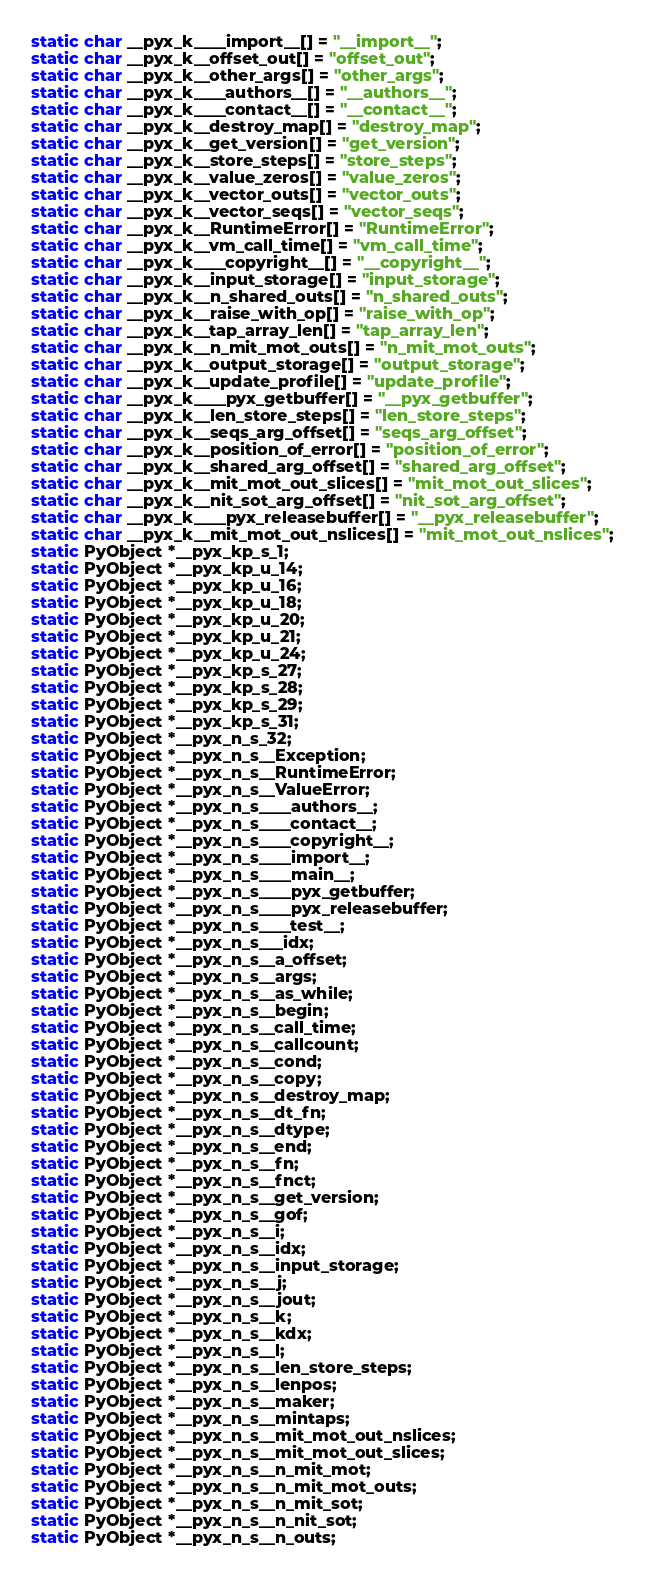<code> <loc_0><loc_0><loc_500><loc_500><_C_>static char __pyx_k____import__[] = "__import__";
static char __pyx_k__offset_out[] = "offset_out";
static char __pyx_k__other_args[] = "other_args";
static char __pyx_k____authors__[] = "__authors__";
static char __pyx_k____contact__[] = "__contact__";
static char __pyx_k__destroy_map[] = "destroy_map";
static char __pyx_k__get_version[] = "get_version";
static char __pyx_k__store_steps[] = "store_steps";
static char __pyx_k__value_zeros[] = "value_zeros";
static char __pyx_k__vector_outs[] = "vector_outs";
static char __pyx_k__vector_seqs[] = "vector_seqs";
static char __pyx_k__RuntimeError[] = "RuntimeError";
static char __pyx_k__vm_call_time[] = "vm_call_time";
static char __pyx_k____copyright__[] = "__copyright__";
static char __pyx_k__input_storage[] = "input_storage";
static char __pyx_k__n_shared_outs[] = "n_shared_outs";
static char __pyx_k__raise_with_op[] = "raise_with_op";
static char __pyx_k__tap_array_len[] = "tap_array_len";
static char __pyx_k__n_mit_mot_outs[] = "n_mit_mot_outs";
static char __pyx_k__output_storage[] = "output_storage";
static char __pyx_k__update_profile[] = "update_profile";
static char __pyx_k____pyx_getbuffer[] = "__pyx_getbuffer";
static char __pyx_k__len_store_steps[] = "len_store_steps";
static char __pyx_k__seqs_arg_offset[] = "seqs_arg_offset";
static char __pyx_k__position_of_error[] = "position_of_error";
static char __pyx_k__shared_arg_offset[] = "shared_arg_offset";
static char __pyx_k__mit_mot_out_slices[] = "mit_mot_out_slices";
static char __pyx_k__nit_sot_arg_offset[] = "nit_sot_arg_offset";
static char __pyx_k____pyx_releasebuffer[] = "__pyx_releasebuffer";
static char __pyx_k__mit_mot_out_nslices[] = "mit_mot_out_nslices";
static PyObject *__pyx_kp_s_1;
static PyObject *__pyx_kp_u_14;
static PyObject *__pyx_kp_u_16;
static PyObject *__pyx_kp_u_18;
static PyObject *__pyx_kp_u_20;
static PyObject *__pyx_kp_u_21;
static PyObject *__pyx_kp_u_24;
static PyObject *__pyx_kp_s_27;
static PyObject *__pyx_kp_s_28;
static PyObject *__pyx_kp_s_29;
static PyObject *__pyx_kp_s_31;
static PyObject *__pyx_n_s_32;
static PyObject *__pyx_n_s__Exception;
static PyObject *__pyx_n_s__RuntimeError;
static PyObject *__pyx_n_s__ValueError;
static PyObject *__pyx_n_s____authors__;
static PyObject *__pyx_n_s____contact__;
static PyObject *__pyx_n_s____copyright__;
static PyObject *__pyx_n_s____import__;
static PyObject *__pyx_n_s____main__;
static PyObject *__pyx_n_s____pyx_getbuffer;
static PyObject *__pyx_n_s____pyx_releasebuffer;
static PyObject *__pyx_n_s____test__;
static PyObject *__pyx_n_s___idx;
static PyObject *__pyx_n_s__a_offset;
static PyObject *__pyx_n_s__args;
static PyObject *__pyx_n_s__as_while;
static PyObject *__pyx_n_s__begin;
static PyObject *__pyx_n_s__call_time;
static PyObject *__pyx_n_s__callcount;
static PyObject *__pyx_n_s__cond;
static PyObject *__pyx_n_s__copy;
static PyObject *__pyx_n_s__destroy_map;
static PyObject *__pyx_n_s__dt_fn;
static PyObject *__pyx_n_s__dtype;
static PyObject *__pyx_n_s__end;
static PyObject *__pyx_n_s__fn;
static PyObject *__pyx_n_s__fnct;
static PyObject *__pyx_n_s__get_version;
static PyObject *__pyx_n_s__gof;
static PyObject *__pyx_n_s__i;
static PyObject *__pyx_n_s__idx;
static PyObject *__pyx_n_s__input_storage;
static PyObject *__pyx_n_s__j;
static PyObject *__pyx_n_s__jout;
static PyObject *__pyx_n_s__k;
static PyObject *__pyx_n_s__kdx;
static PyObject *__pyx_n_s__l;
static PyObject *__pyx_n_s__len_store_steps;
static PyObject *__pyx_n_s__lenpos;
static PyObject *__pyx_n_s__maker;
static PyObject *__pyx_n_s__mintaps;
static PyObject *__pyx_n_s__mit_mot_out_nslices;
static PyObject *__pyx_n_s__mit_mot_out_slices;
static PyObject *__pyx_n_s__n_mit_mot;
static PyObject *__pyx_n_s__n_mit_mot_outs;
static PyObject *__pyx_n_s__n_mit_sot;
static PyObject *__pyx_n_s__n_nit_sot;
static PyObject *__pyx_n_s__n_outs;</code> 